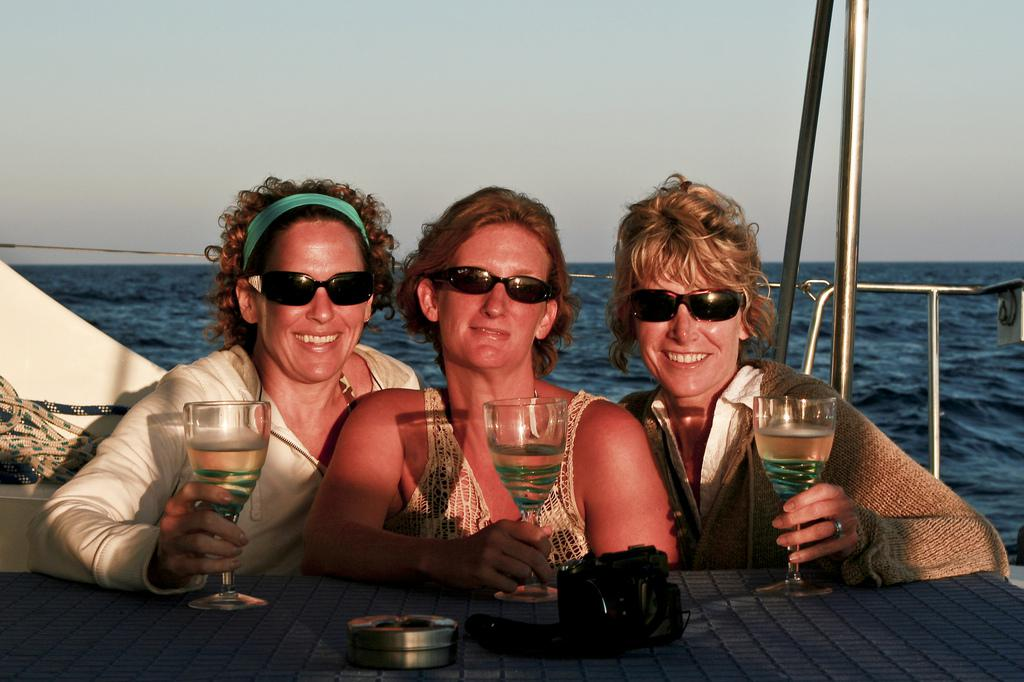Question: how big are the glasses?
Choices:
A. Medium.
B. Small.
C. Extra large.
D. Large.
Answer with the letter. Answer: D Question: how many women are there?
Choices:
A. Three.
B. Ten.
C. Fitteen.
D. Twenty.
Answer with the letter. Answer: A Question: how is the weather?
Choices:
A. Cloudy.
B. Raining.
C. Snowing.
D. It's sunny.
Answer with the letter. Answer: D Question: where are the women?
Choices:
A. In a car.
B. On a bench.
C. On a couch.
D. On a boat.
Answer with the letter. Answer: D Question: what are they looking at?
Choices:
A. A tree.
B. A mountain.
C. The sunset.
D. A house.
Answer with the letter. Answer: C Question: what are the women wearing?
Choices:
A. Visors.
B. Sunglasses.
C. Hats.
D. Scarves.
Answer with the letter. Answer: B Question: where was the photo taken?
Choices:
A. On a deserted beach.
B. Ocean.
C. By the marina in town.
D. Near the docks.
Answer with the letter. Answer: B Question: how many ladies have a glass in their right hand?
Choices:
A. Five.
B. Six.
C. Two.
D. Seven.
Answer with the letter. Answer: C Question: where are the women?
Choices:
A. On a plane.
B. At sea.
C. On a train.
D. In a car.
Answer with the letter. Answer: B Question: what has swirls at the bottom?
Choices:
A. The beer bottle.
B. The liquor bottle.
C. The wine glasses.
D. The soda bottle.
Answer with the letter. Answer: C Question: what is on the table?
Choices:
A. A glass.
B. A cat.
C. A camera.
D. A tray.
Answer with the letter. Answer: C Question: how many people do you see?
Choices:
A. 3 people.
B. Three.
C. Three people.
D. 3.
Answer with the letter. Answer: D Question: how many women are there?
Choices:
A. 3.
B. Three.
C. Three women.
D. 3 women.
Answer with the letter. Answer: A Question: what are the women wearing?
Choices:
A. Hats.
B. Suits.
C. Sunglasses.
D. Sandals.
Answer with the letter. Answer: C Question: who is sunburned the most?
Choices:
A. The man on the boat.
B. The woman on the pool float.
C. The girl on the beach chair.
D. The woman in the middle.
Answer with the letter. Answer: D Question: what are they drinking?
Choices:
A. Water.
B. Alcohol.
C. Soda.
D. Coffee.
Answer with the letter. Answer: B Question: who isn't smiling?
Choices:
A. The woman on the right.
B. The woman on the left.
C. The woman in the middle.
D. Everyone is smiling.
Answer with the letter. Answer: C Question: where is ashtray?
Choices:
A. On the table.
B. On the counter.
C. On the tray.
D. On the platter..
Answer with the letter. Answer: A Question: who is enjoying cocktails?
Choices:
A. Men.
B. Doctors.
C. Women.
D. Teachers.
Answer with the letter. Answer: C Question: who is on a boat?
Choices:
A. Men.
B. Children.
C. Captain.
D. Women.
Answer with the letter. Answer: D Question: what is golden?
Choices:
A. The setting sun.
B. A woman's hair.
C. A tiger's eyes.
D. Liquid in the glasses.
Answer with the letter. Answer: D Question: what looks calm?
Choices:
A. The sky.
B. The baby.
C. The crowd.
D. The water.
Answer with the letter. Answer: D Question: what are the women wearing on their faces?
Choices:
A. Seeing glasses.
B. Masks.
C. Sunglasses.
D. Bandannas.
Answer with the letter. Answer: C 